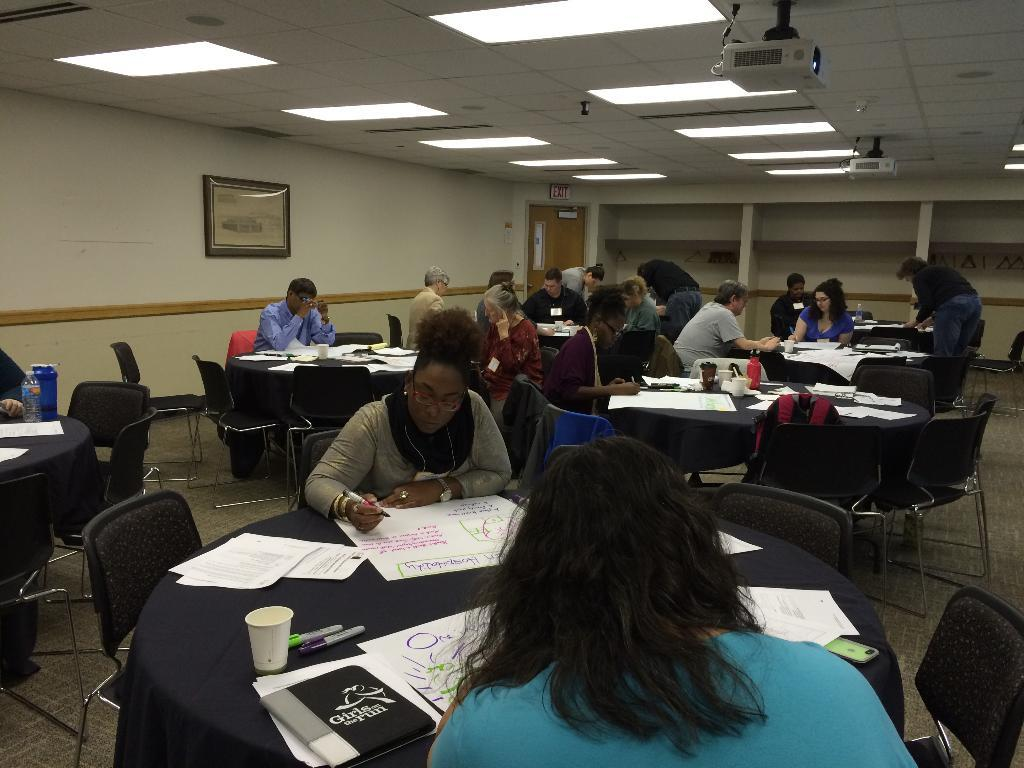How many people are in the image? There is a group of people in the image. What are the people doing in the image? The people are sitting on chairs. Where are the chairs located in relation to the table? The chairs are in front of a table. What can be found on the table in the image? There is a cup, papers, and other objects on the table. What type of brush is being used to clean the toothbrush in the image? There is no brush or toothbrush present in the image. 